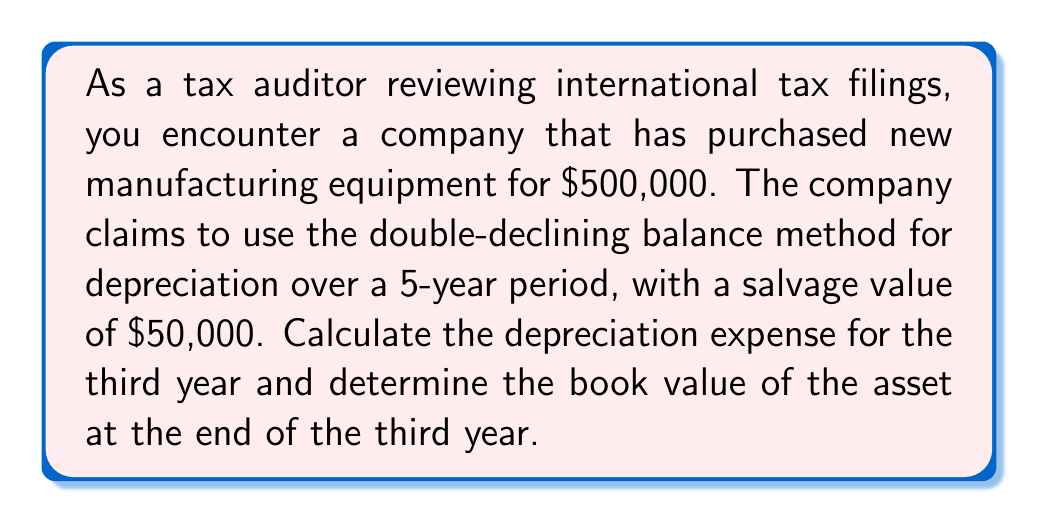Help me with this question. To solve this problem, we'll use the double-declining balance method of depreciation. Here are the steps:

1. Calculate the annual depreciation rate:
   $$\text{Annual rate} = \frac{2}{\text{Useful life}} = \frac{2}{5} = 0.4 \text{ or } 40\%$$

2. Calculate the depreciation for each year:
   Year 1: $$\text{Depreciation} = 500,000 \times 0.4 = 200,000$$
   Book value after Year 1: $$500,000 - 200,000 = 300,000$$

   Year 2: $$\text{Depreciation} = 300,000 \times 0.4 = 120,000$$
   Book value after Year 2: $$300,000 - 120,000 = 180,000$$

   Year 3: $$\text{Depreciation} = 180,000 \times 0.4 = 72,000$$
   Book value after Year 3: $$180,000 - 72,000 = 108,000$$

3. Check if the book value is less than the salvage value:
   The book value after Year 3 ($108,000) is greater than the salvage value ($50,000), so we don't need to adjust the depreciation.

Therefore, the depreciation expense for the third year is $72,000, and the book value of the asset at the end of the third year is $108,000.
Answer: Depreciation expense for the third year: $72,000
Book value at the end of the third year: $108,000 